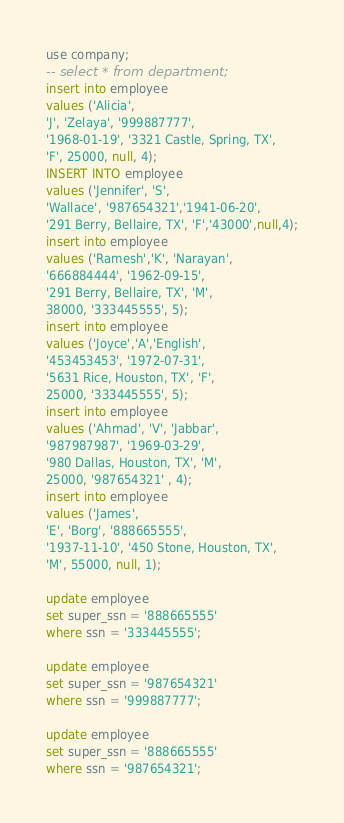Convert code to text. <code><loc_0><loc_0><loc_500><loc_500><_SQL_>use company;
-- select * from department;
insert into employee
values ('Alicia', 
'J', 'Zelaya', '999887777', 
'1968-01-19', '3321 Castle, Spring, TX', 
'F', 25000, null, 4);
INSERT INTO employee
values ('Jennifer', 'S', 
'Wallace', '987654321','1941-06-20', 
'291 Berry, Bellaire, TX', 'F','43000',null,4);
insert into employee
values ('Ramesh','K', 'Narayan', 
'666884444', '1962-09-15', 
'291 Berry, Bellaire, TX', 'M', 
38000, '333445555', 5);
insert into employee
values ('Joyce','A','English', 
'453453453', '1972-07-31', 
'5631 Rice, Houston, TX', 'F', 
25000, '333445555', 5);
insert into employee
values ('Ahmad', 'V', 'Jabbar', 
'987987987', '1969-03-29', 
'980 Dallas, Houston, TX', 'M', 
25000, '987654321' , 4);
insert into employee
values ('James', 
'E', 'Borg', '888665555', 
'1937-11-10', '450 Stone, Houston, TX', 
'M', 55000, null, 1);

update employee
set super_ssn = '888665555'
where ssn = '333445555';

update employee
set super_ssn = '987654321'
where ssn = '999887777';

update employee
set super_ssn = '888665555'
where ssn = '987654321';







</code> 